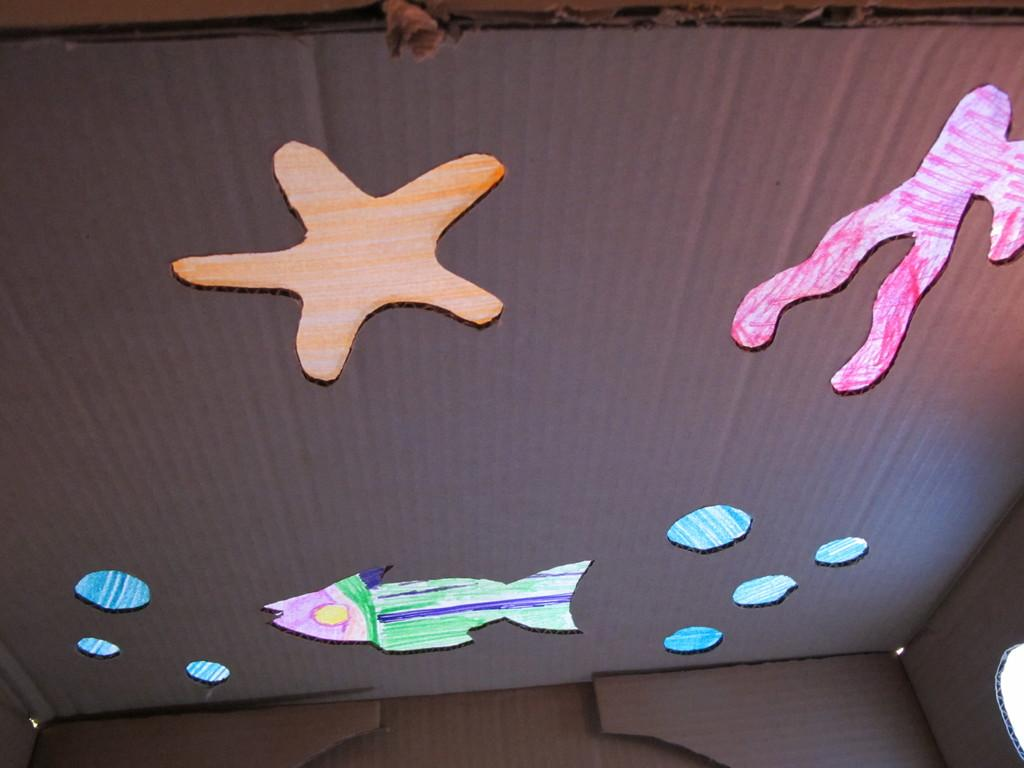What is the main object in the image? There is a cardboard box in the image. What decorations are attached to the cardboard box? The cardboard box has paper cuttings of a star and a fish attached to it. What type of slope can be seen in the image? There is no slope present in the image; it features a cardboard box with paper cuttings of a star and a fish. 